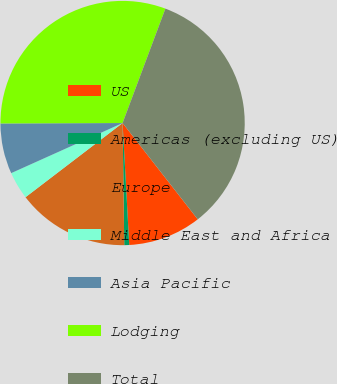Convert chart to OTSL. <chart><loc_0><loc_0><loc_500><loc_500><pie_chart><fcel>US<fcel>Americas (excluding US)<fcel>Europe<fcel>Middle East and Africa<fcel>Asia Pacific<fcel>Lodging<fcel>Total<nl><fcel>9.68%<fcel>0.65%<fcel>14.83%<fcel>3.66%<fcel>6.67%<fcel>30.75%<fcel>33.75%<nl></chart> 